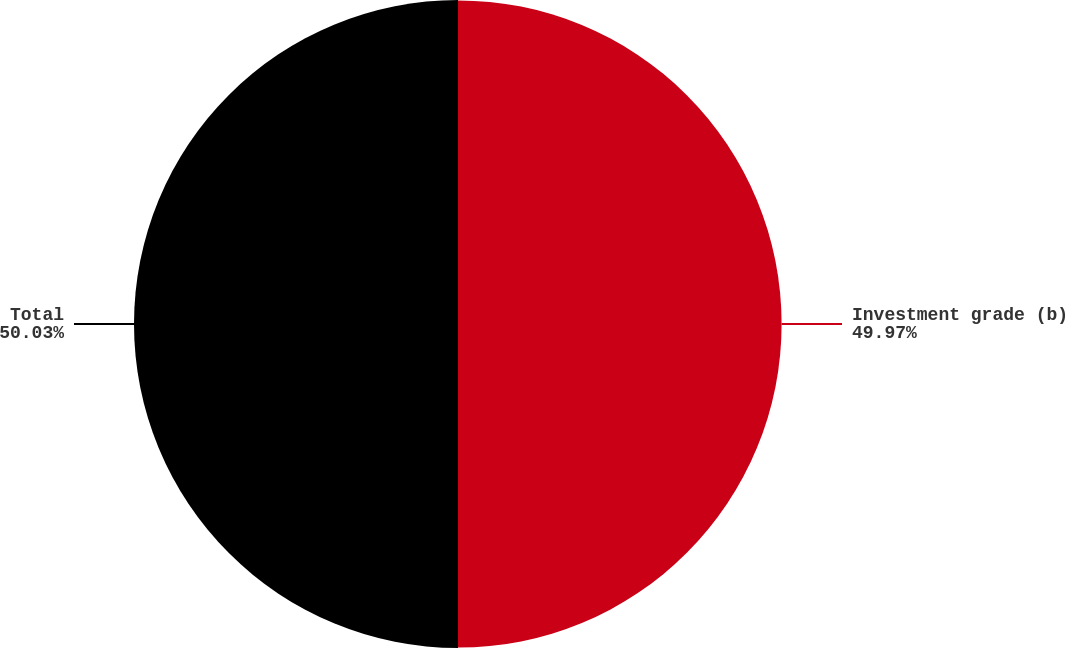Convert chart to OTSL. <chart><loc_0><loc_0><loc_500><loc_500><pie_chart><fcel>Investment grade (b)<fcel>Total<nl><fcel>49.97%<fcel>50.03%<nl></chart> 